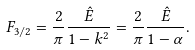<formula> <loc_0><loc_0><loc_500><loc_500>F _ { 3 / 2 } = \frac { 2 } { \pi } \frac { { \hat { E } } } { 1 - k ^ { 2 } } = \frac { 2 } { \pi } \frac { { \hat { E } } } { 1 - \alpha } .</formula> 